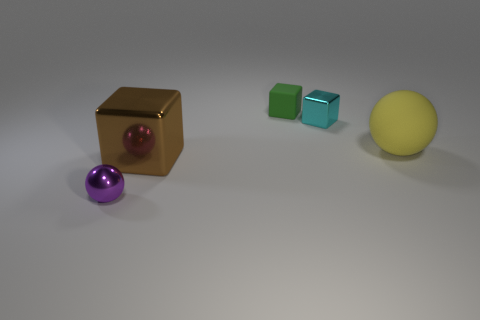Add 1 small gray rubber things. How many objects exist? 6 Subtract all big metallic objects. Subtract all tiny green matte cubes. How many objects are left? 3 Add 3 small spheres. How many small spheres are left? 4 Add 1 big brown matte spheres. How many big brown matte spheres exist? 1 Subtract 0 green spheres. How many objects are left? 5 Subtract all spheres. How many objects are left? 3 